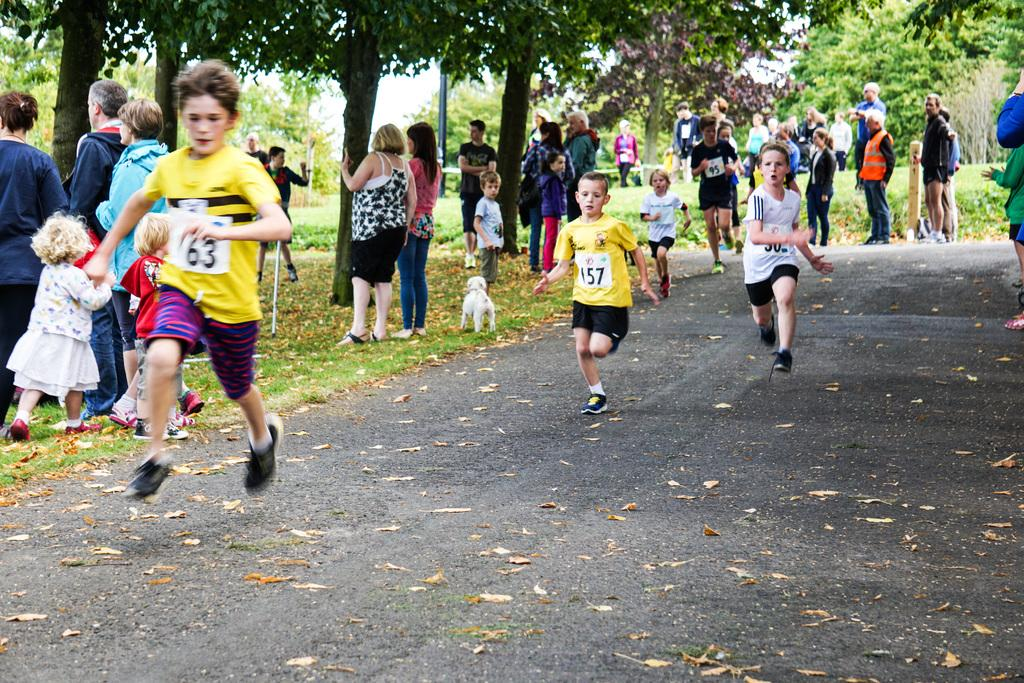What is happening in the image involving a group of people? There is a group of people in the image, and three of them are running. How can you describe the appearance of the running people? The running people are wearing different color dresses. What other objects or elements can be seen in the image? There are trees, a pole, and a dog in the image. What is the color of the sky in the image? The sky appears to be white in color. How many elbows can be seen on the trees in the image? There are no elbows present on the trees in the image, as trees do not have elbows. What type of horn is being played by the dog in the image? There is no horn being played by the dog in the image, as dogs do not play horns. 